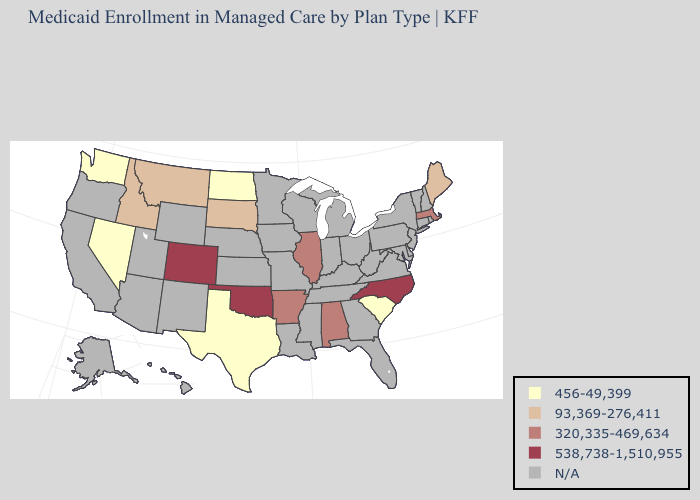Name the states that have a value in the range 320,335-469,634?
Give a very brief answer. Alabama, Arkansas, Illinois, Massachusetts. What is the value of Michigan?
Be succinct. N/A. What is the lowest value in states that border North Dakota?
Short answer required. 93,369-276,411. Name the states that have a value in the range 93,369-276,411?
Give a very brief answer. Idaho, Maine, Montana, South Dakota. Name the states that have a value in the range 538,738-1,510,955?
Be succinct. Colorado, North Carolina, Oklahoma. What is the value of Pennsylvania?
Answer briefly. N/A. Name the states that have a value in the range 320,335-469,634?
Keep it brief. Alabama, Arkansas, Illinois, Massachusetts. Name the states that have a value in the range 456-49,399?
Quick response, please. Nevada, North Dakota, South Carolina, Texas, Washington. How many symbols are there in the legend?
Answer briefly. 5. Among the states that border Vermont , which have the highest value?
Short answer required. Massachusetts. What is the value of Alabama?
Quick response, please. 320,335-469,634. Does the first symbol in the legend represent the smallest category?
Answer briefly. Yes. 